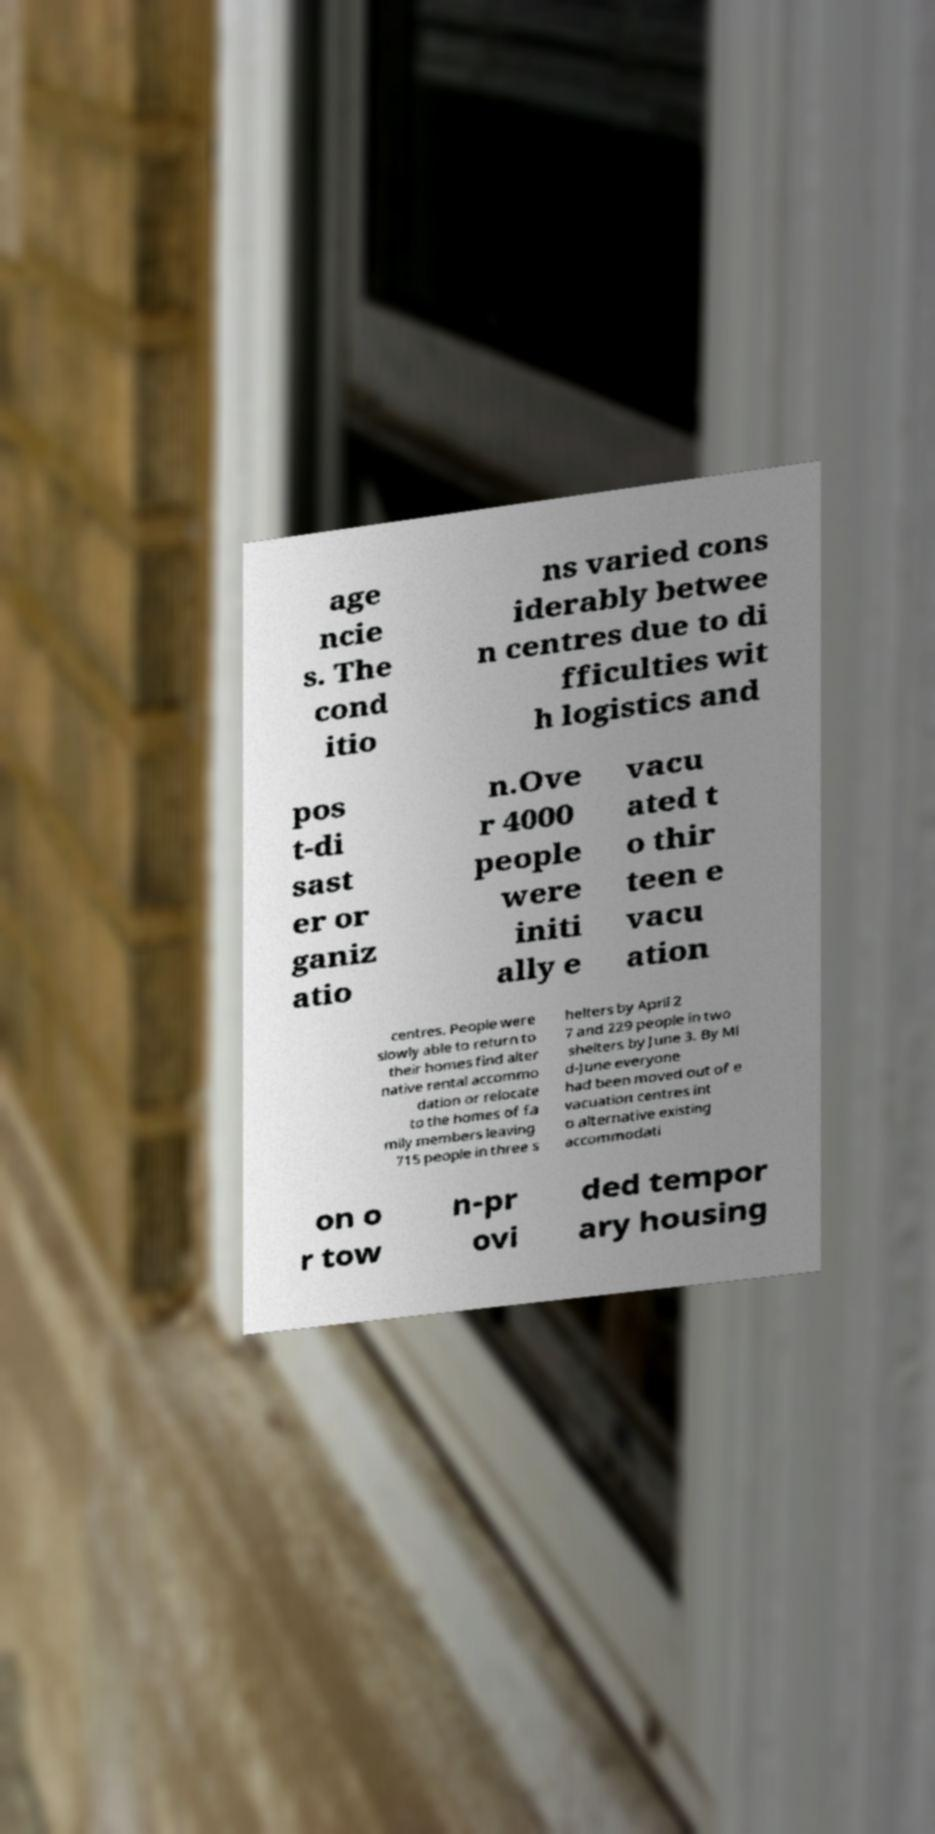I need the written content from this picture converted into text. Can you do that? age ncie s. The cond itio ns varied cons iderably betwee n centres due to di fficulties wit h logistics and pos t-di sast er or ganiz atio n.Ove r 4000 people were initi ally e vacu ated t o thir teen e vacu ation centres. People were slowly able to return to their homes find alter native rental accommo dation or relocate to the homes of fa mily members leaving 715 people in three s helters by April 2 7 and 229 people in two shelters by June 3. By Mi d-June everyone had been moved out of e vacuation centres int o alternative existing accommodati on o r tow n-pr ovi ded tempor ary housing 